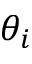Convert formula to latex. <formula><loc_0><loc_0><loc_500><loc_500>\theta _ { i }</formula> 